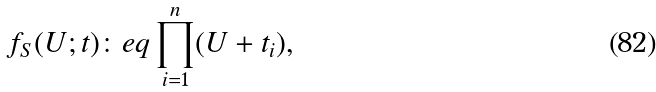<formula> <loc_0><loc_0><loc_500><loc_500>f _ { S } ( U ; t ) \colon e q \prod _ { i = 1 } ^ { n } ( U + t _ { i } ) ,</formula> 